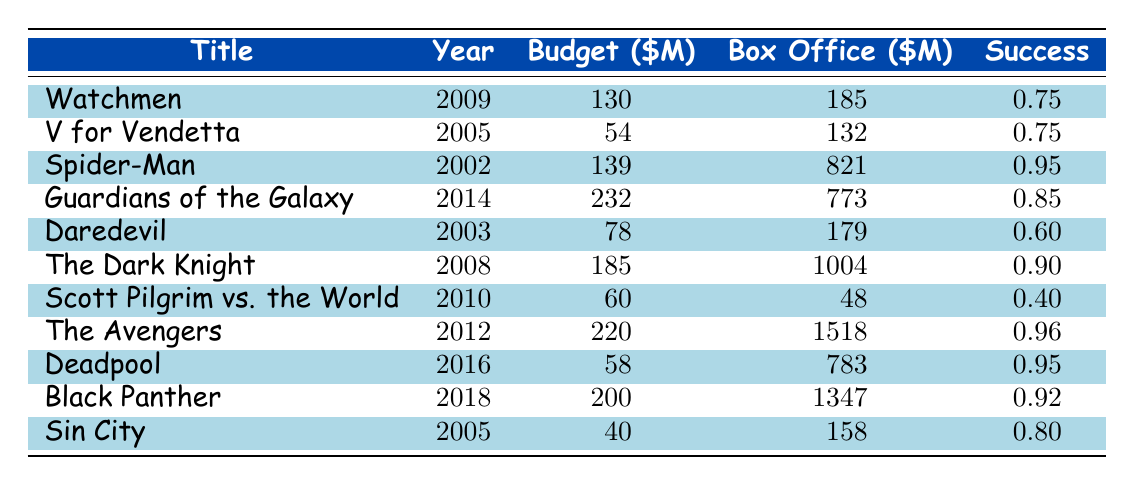What is the budget of "Guardians of the Galaxy"? The budget for "Guardians of the Galaxy" is listed in the table under the budget column for that title, which is 232 million dollars.
Answer: 232 million Which movie had the highest box office performance? By looking at the box office column, "The Avengers" has the highest value at 1518 million dollars, more than any other film in the list.
Answer: The Avengers What is the adaptation success rate of "Scott Pilgrim vs. the World"? The adaptation success for "Scott Pilgrim vs. the World" is shown in the success column, which is 0.40.
Answer: 0.40 What is the average budget of all the adaptations listed? The total budget for all adaptations is 130 + 54 + 139 + 232 + 78 + 185 + 60 + 220 + 58 + 200 + 40 = 1,223. There are 11 adaptations, so the average budget is 1,223 / 11 = 111.18 million.
Answer: 111.18 million Is the adaptation success for "Daredevil" greater than 0.7? The success value for "Daredevil" is 0.60, which is less than 0.7, thus it is true that the adaptation success is not greater than 0.7.
Answer: No What is the difference in box office revenue between "Deadpool" and "Scott Pilgrim vs. the World"? "Deadpool" has a box office revenue of 783 million, while "Scott Pilgrim vs. the World" has 48 million. The difference is 783 - 48 = 735 million.
Answer: 735 million Which comic creator had the highest box office adaptation on the list? Reviewing the box office column, "Stan Lee & Jack Kirby" associated with "The Avengers" generated 1518 million, which is the highest.
Answer: Stan Lee & Jack Kirby Which film has the lowest adaptation success rating, and what is that rating? The rating for "Scott Pilgrim vs. the World" is 0.40, which is the smallest value among the listed adaptations, indicating the lowest adaptation success.
Answer: Scott Pilgrim vs. the World, 0.40 How many adaptations have a budget of less than 100 million? Upon checking the budget column, the adaptations with budgets under 100 million are "V for Vendetta" (54), "Daredevil" (78), "Scott Pilgrim vs. the World" (60), and "Sin City" (40), totaling four adaptations.
Answer: Four 